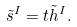Convert formula to latex. <formula><loc_0><loc_0><loc_500><loc_500>\tilde { s } ^ { I } = t \tilde { h } ^ { I } .</formula> 